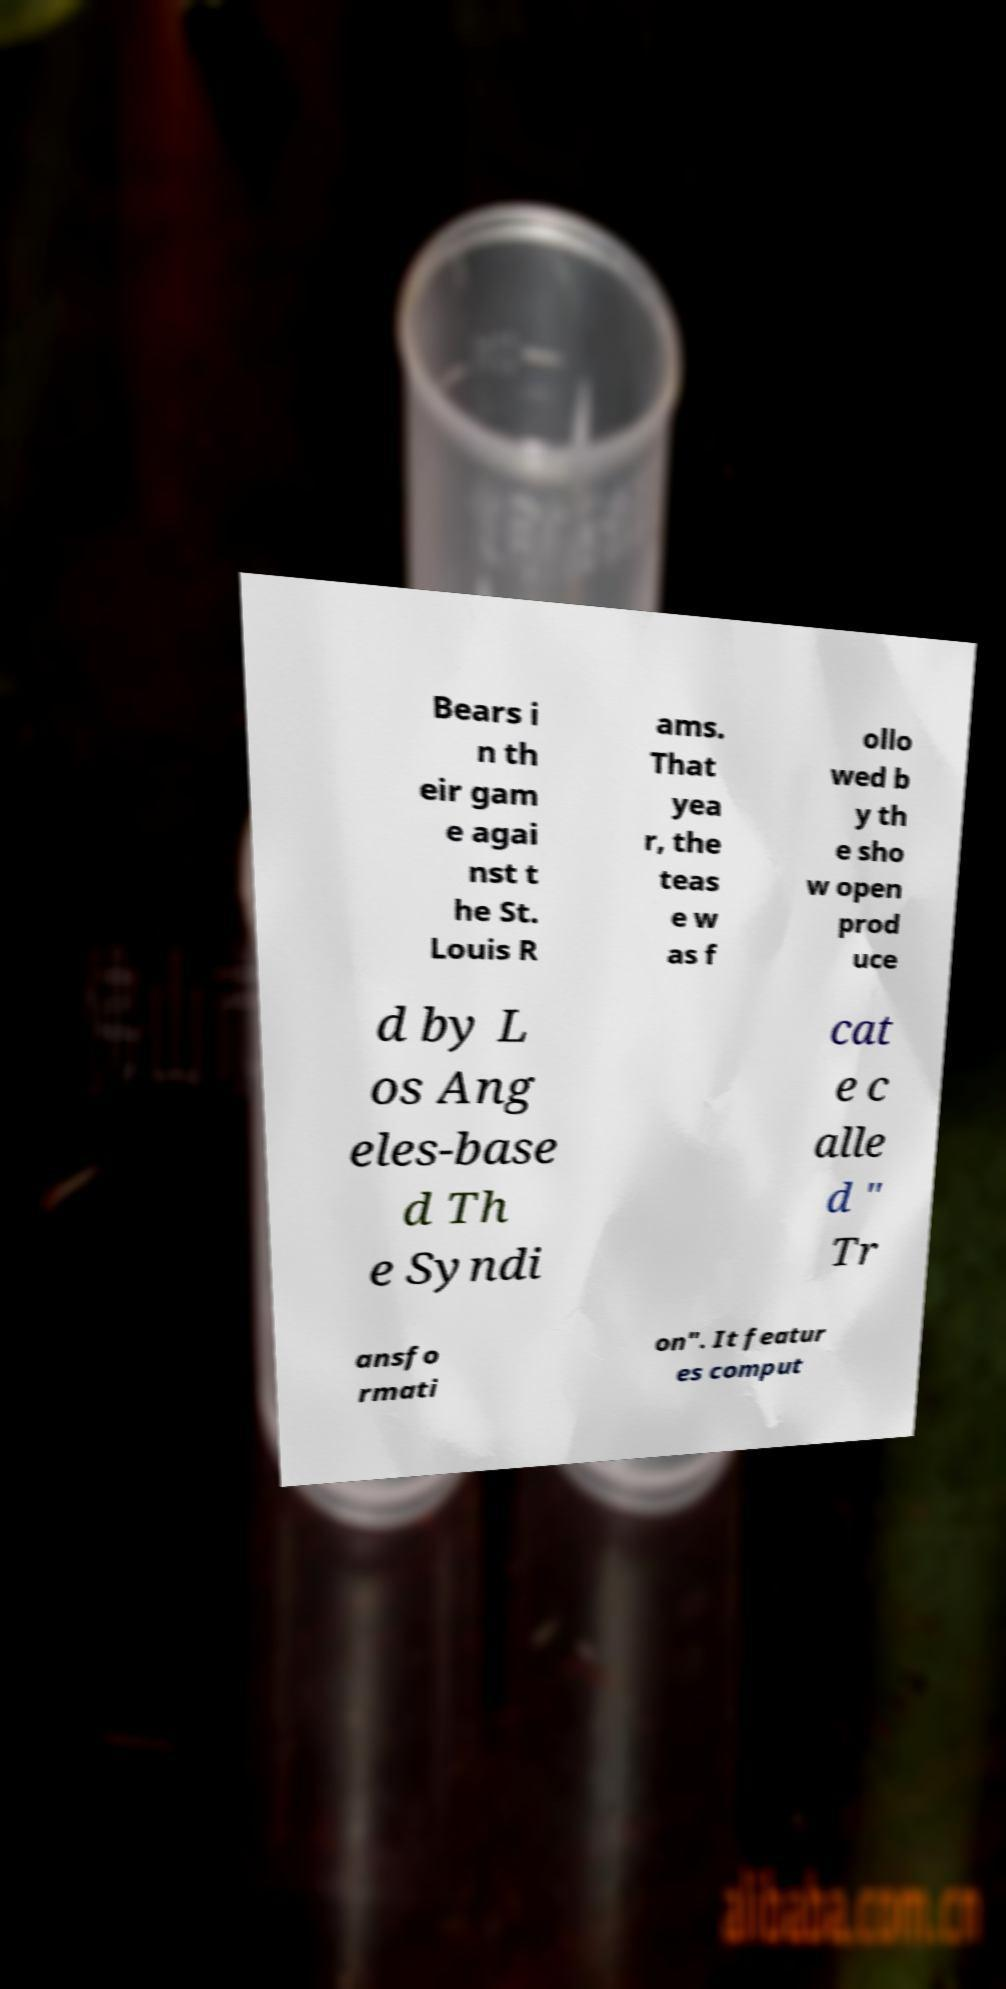Can you accurately transcribe the text from the provided image for me? Bears i n th eir gam e agai nst t he St. Louis R ams. That yea r, the teas e w as f ollo wed b y th e sho w open prod uce d by L os Ang eles-base d Th e Syndi cat e c alle d " Tr ansfo rmati on". It featur es comput 